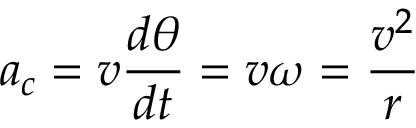Convert formula to latex. <formula><loc_0><loc_0><loc_500><loc_500>a _ { c } = v { \frac { d \theta } { d t } } = v \omega = { \frac { v ^ { 2 } } { r } }</formula> 